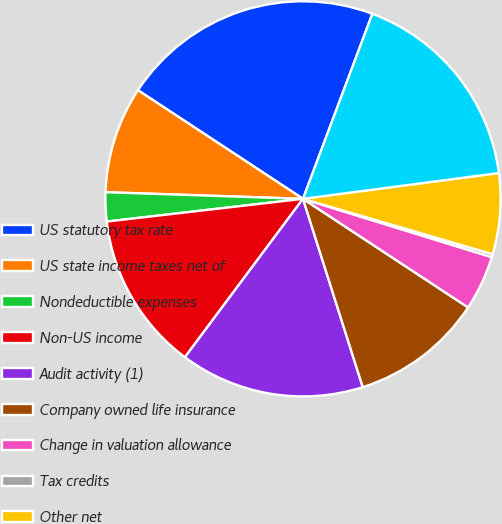Convert chart. <chart><loc_0><loc_0><loc_500><loc_500><pie_chart><fcel>US statutory tax rate<fcel>US state income taxes net of<fcel>Nondeductible expenses<fcel>Non-US income<fcel>Audit activity (1)<fcel>Company owned life insurance<fcel>Change in valuation allowance<fcel>Tax credits<fcel>Other net<fcel>Effective rate<nl><fcel>21.45%<fcel>8.73%<fcel>2.37%<fcel>12.97%<fcel>15.09%<fcel>10.85%<fcel>4.49%<fcel>0.25%<fcel>6.61%<fcel>17.21%<nl></chart> 